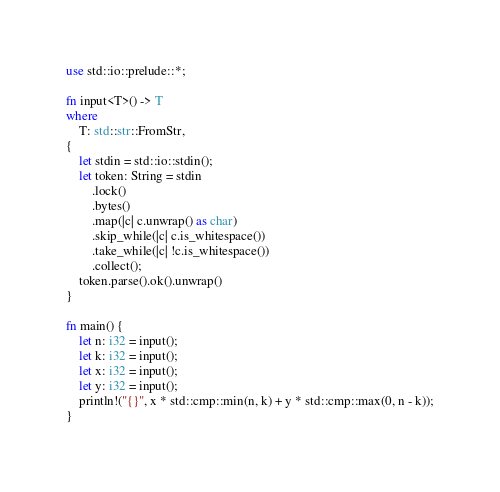Convert code to text. <code><loc_0><loc_0><loc_500><loc_500><_Rust_>use std::io::prelude::*;

fn input<T>() -> T
where
    T: std::str::FromStr,
{
    let stdin = std::io::stdin();
    let token: String = stdin
        .lock()
        .bytes()
        .map(|c| c.unwrap() as char)
        .skip_while(|c| c.is_whitespace())
        .take_while(|c| !c.is_whitespace())
        .collect();
    token.parse().ok().unwrap()
}

fn main() {
    let n: i32 = input();
    let k: i32 = input();
    let x: i32 = input();
    let y: i32 = input();
    println!("{}", x * std::cmp::min(n, k) + y * std::cmp::max(0, n - k));
}
</code> 